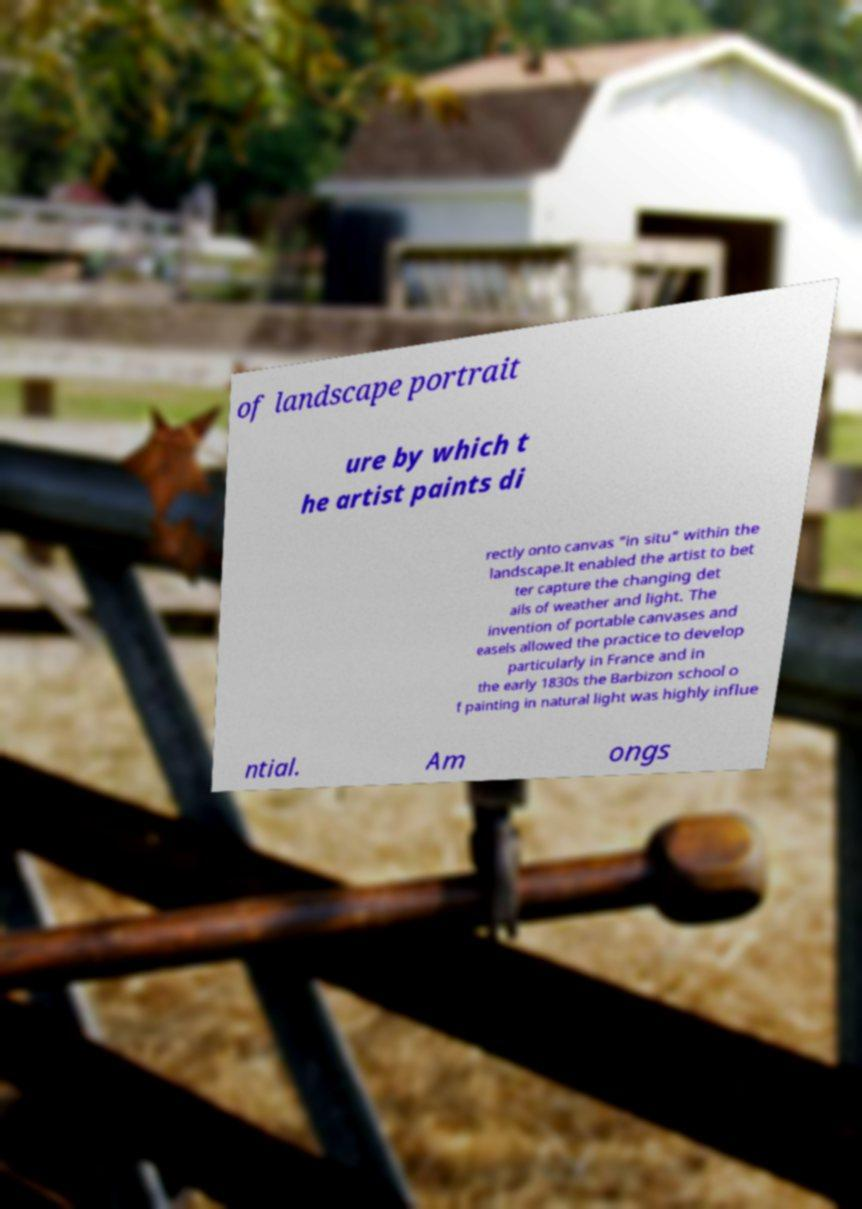Can you read and provide the text displayed in the image?This photo seems to have some interesting text. Can you extract and type it out for me? of landscape portrait ure by which t he artist paints di rectly onto canvas "in situ" within the landscape.It enabled the artist to bet ter capture the changing det ails of weather and light. The invention of portable canvases and easels allowed the practice to develop particularly in France and in the early 1830s the Barbizon school o f painting in natural light was highly influe ntial. Am ongs 